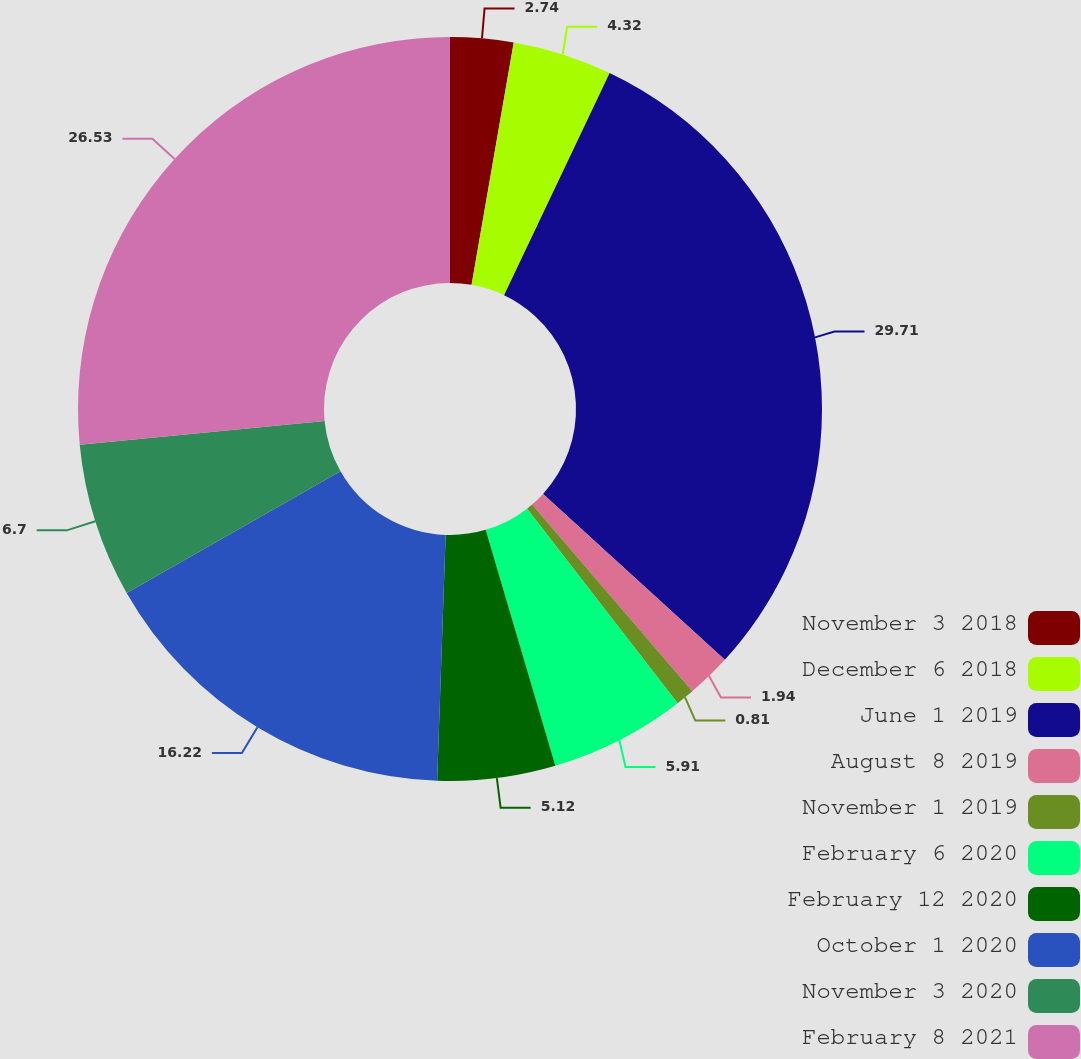Convert chart to OTSL. <chart><loc_0><loc_0><loc_500><loc_500><pie_chart><fcel>November 3 2018<fcel>December 6 2018<fcel>June 1 2019<fcel>August 8 2019<fcel>November 1 2019<fcel>February 6 2020<fcel>February 12 2020<fcel>October 1 2020<fcel>November 3 2020<fcel>February 8 2021<nl><fcel>2.74%<fcel>4.32%<fcel>29.71%<fcel>1.94%<fcel>0.81%<fcel>5.91%<fcel>5.12%<fcel>16.22%<fcel>6.7%<fcel>26.53%<nl></chart> 